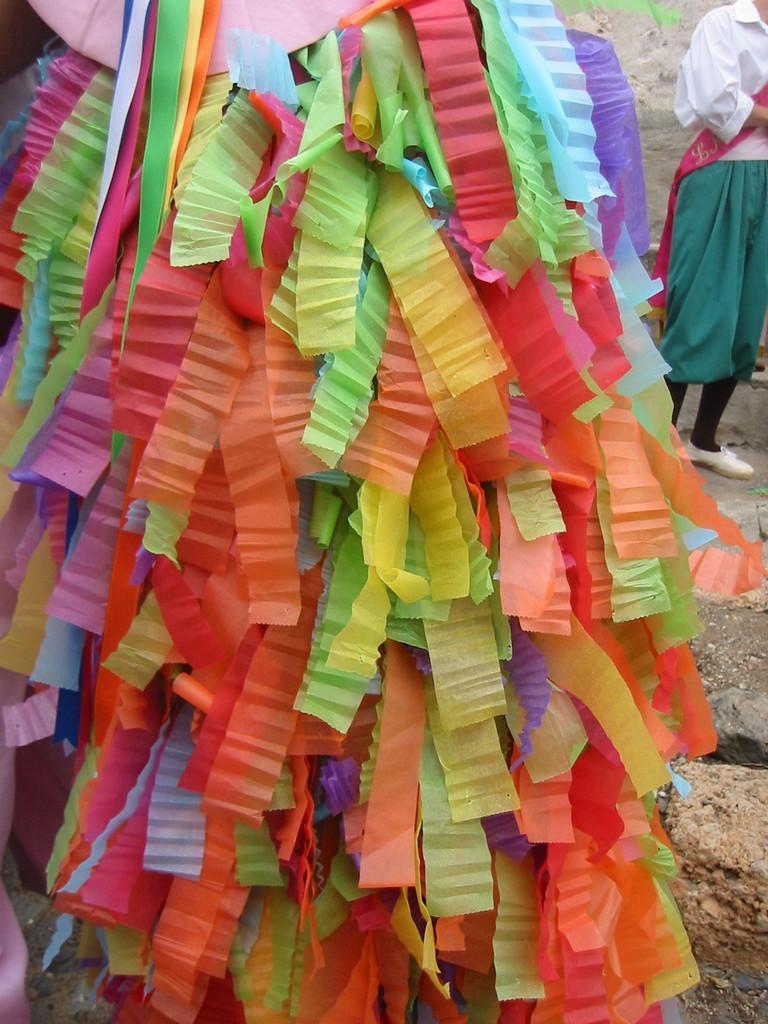In one or two sentences, can you explain what this image depicts? In the foreground of the picture we can see various colored ribbons. Towards right we can see land and a person standing. 